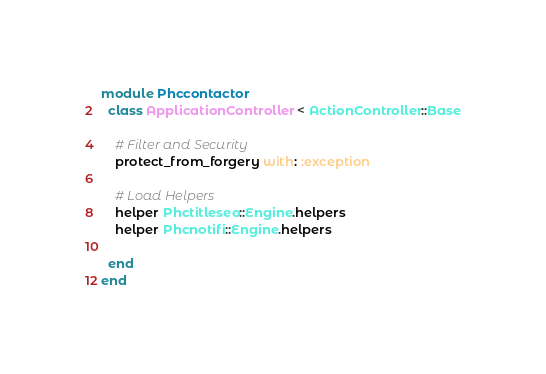Convert code to text. <code><loc_0><loc_0><loc_500><loc_500><_Ruby_>module Phccontactor
  class ApplicationController < ActionController::Base

    # Filter and Security
    protect_from_forgery with: :exception

    # Load Helpers
    helper Phctitleseo::Engine.helpers
    helper Phcnotifi::Engine.helpers

  end
end
</code> 